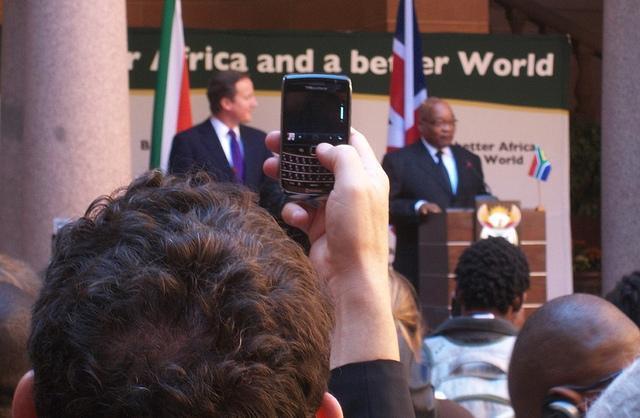How many people are in the photo?
Give a very brief answer. 6. 